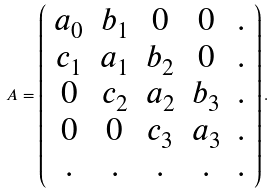Convert formula to latex. <formula><loc_0><loc_0><loc_500><loc_500>A = \left ( \begin{array} { c c c c c } a _ { 0 } & b _ { 1 } & 0 & 0 & . \\ c _ { 1 } & a _ { 1 } & b _ { 2 } & 0 & . \\ 0 & c _ { 2 } & a _ { 2 } & b _ { 3 } & . \\ 0 & 0 & c _ { 3 } & a _ { 3 } & . \\ . & . & . & . & . \end{array} \right ) .</formula> 